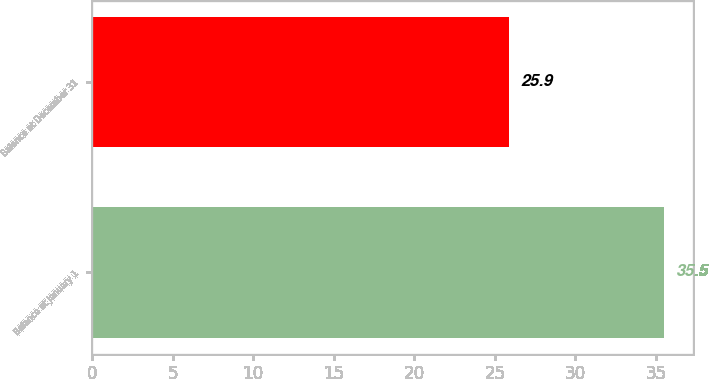<chart> <loc_0><loc_0><loc_500><loc_500><bar_chart><fcel>Balance at January 1<fcel>Balance at December 31<nl><fcel>35.5<fcel>25.9<nl></chart> 